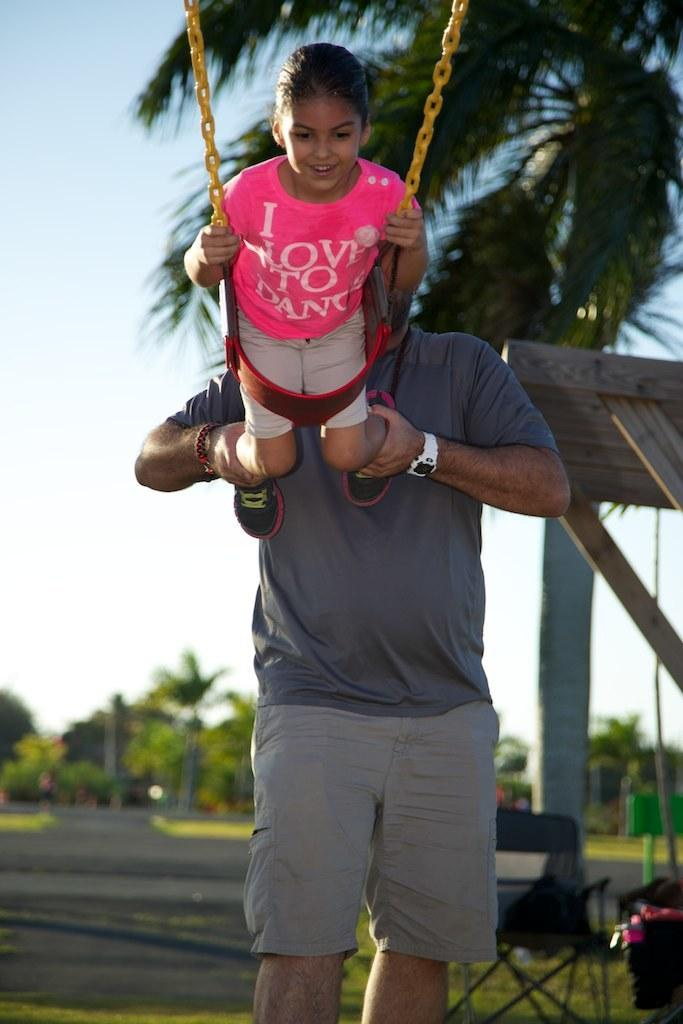Who is present in the image? There is a person and a kid in the image. What are the person and kid doing in the image? The person and kid are in a swing. What can be seen in the background of the image? There is a chair, trees, grass, and the sky visible in the background of the image. What type of vest is the calculator wearing in the image? There is no calculator or vest present in the image. 